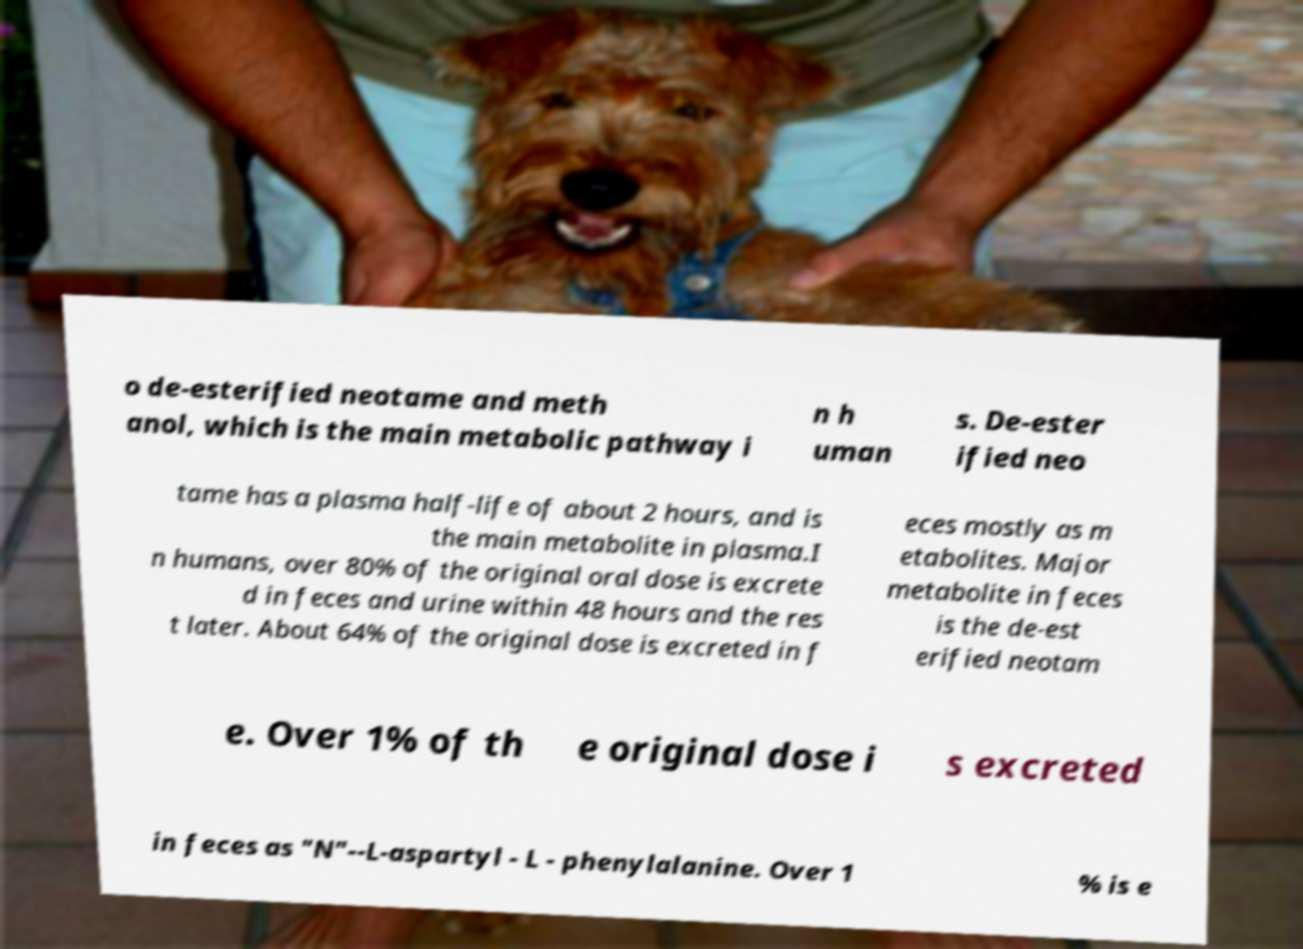Please read and relay the text visible in this image. What does it say? o de-esterified neotame and meth anol, which is the main metabolic pathway i n h uman s. De-ester ified neo tame has a plasma half-life of about 2 hours, and is the main metabolite in plasma.I n humans, over 80% of the original oral dose is excrete d in feces and urine within 48 hours and the res t later. About 64% of the original dose is excreted in f eces mostly as m etabolites. Major metabolite in feces is the de-est erified neotam e. Over 1% of th e original dose i s excreted in feces as "N"--L-aspartyl - L - phenylalanine. Over 1 % is e 